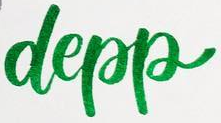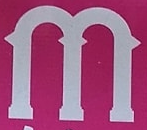Read the text from these images in sequence, separated by a semicolon. depp; m 